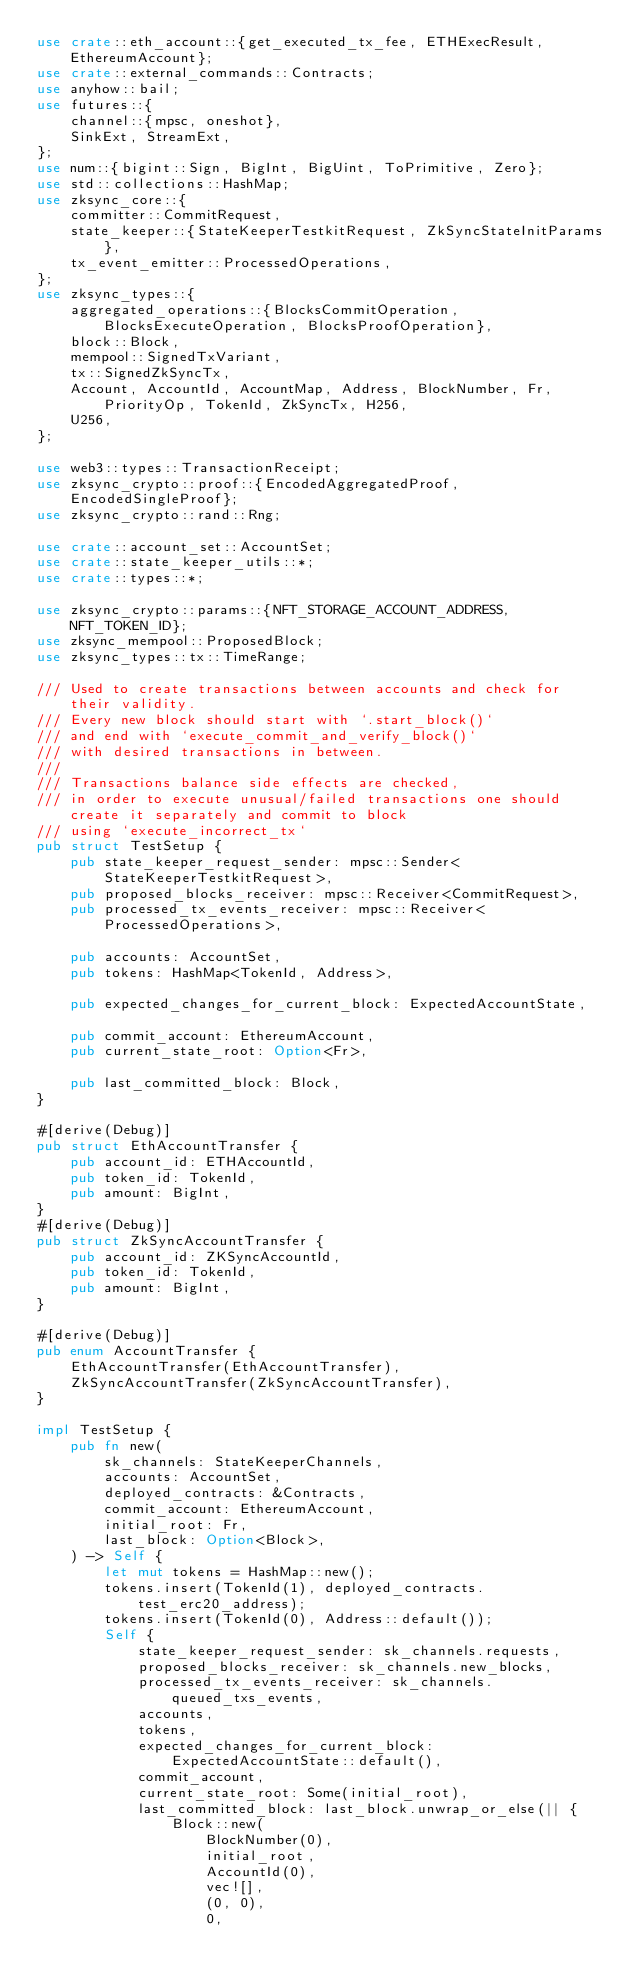Convert code to text. <code><loc_0><loc_0><loc_500><loc_500><_Rust_>use crate::eth_account::{get_executed_tx_fee, ETHExecResult, EthereumAccount};
use crate::external_commands::Contracts;
use anyhow::bail;
use futures::{
    channel::{mpsc, oneshot},
    SinkExt, StreamExt,
};
use num::{bigint::Sign, BigInt, BigUint, ToPrimitive, Zero};
use std::collections::HashMap;
use zksync_core::{
    committer::CommitRequest,
    state_keeper::{StateKeeperTestkitRequest, ZkSyncStateInitParams},
    tx_event_emitter::ProcessedOperations,
};
use zksync_types::{
    aggregated_operations::{BlocksCommitOperation, BlocksExecuteOperation, BlocksProofOperation},
    block::Block,
    mempool::SignedTxVariant,
    tx::SignedZkSyncTx,
    Account, AccountId, AccountMap, Address, BlockNumber, Fr, PriorityOp, TokenId, ZkSyncTx, H256,
    U256,
};

use web3::types::TransactionReceipt;
use zksync_crypto::proof::{EncodedAggregatedProof, EncodedSingleProof};
use zksync_crypto::rand::Rng;

use crate::account_set::AccountSet;
use crate::state_keeper_utils::*;
use crate::types::*;

use zksync_crypto::params::{NFT_STORAGE_ACCOUNT_ADDRESS, NFT_TOKEN_ID};
use zksync_mempool::ProposedBlock;
use zksync_types::tx::TimeRange;

/// Used to create transactions between accounts and check for their validity.
/// Every new block should start with `.start_block()`
/// and end with `execute_commit_and_verify_block()`
/// with desired transactions in between.
///
/// Transactions balance side effects are checked,
/// in order to execute unusual/failed transactions one should create it separately and commit to block
/// using `execute_incorrect_tx`
pub struct TestSetup {
    pub state_keeper_request_sender: mpsc::Sender<StateKeeperTestkitRequest>,
    pub proposed_blocks_receiver: mpsc::Receiver<CommitRequest>,
    pub processed_tx_events_receiver: mpsc::Receiver<ProcessedOperations>,

    pub accounts: AccountSet,
    pub tokens: HashMap<TokenId, Address>,

    pub expected_changes_for_current_block: ExpectedAccountState,

    pub commit_account: EthereumAccount,
    pub current_state_root: Option<Fr>,

    pub last_committed_block: Block,
}

#[derive(Debug)]
pub struct EthAccountTransfer {
    pub account_id: ETHAccountId,
    pub token_id: TokenId,
    pub amount: BigInt,
}
#[derive(Debug)]
pub struct ZkSyncAccountTransfer {
    pub account_id: ZKSyncAccountId,
    pub token_id: TokenId,
    pub amount: BigInt,
}

#[derive(Debug)]
pub enum AccountTransfer {
    EthAccountTransfer(EthAccountTransfer),
    ZkSyncAccountTransfer(ZkSyncAccountTransfer),
}

impl TestSetup {
    pub fn new(
        sk_channels: StateKeeperChannels,
        accounts: AccountSet,
        deployed_contracts: &Contracts,
        commit_account: EthereumAccount,
        initial_root: Fr,
        last_block: Option<Block>,
    ) -> Self {
        let mut tokens = HashMap::new();
        tokens.insert(TokenId(1), deployed_contracts.test_erc20_address);
        tokens.insert(TokenId(0), Address::default());
        Self {
            state_keeper_request_sender: sk_channels.requests,
            proposed_blocks_receiver: sk_channels.new_blocks,
            processed_tx_events_receiver: sk_channels.queued_txs_events,
            accounts,
            tokens,
            expected_changes_for_current_block: ExpectedAccountState::default(),
            commit_account,
            current_state_root: Some(initial_root),
            last_committed_block: last_block.unwrap_or_else(|| {
                Block::new(
                    BlockNumber(0),
                    initial_root,
                    AccountId(0),
                    vec![],
                    (0, 0),
                    0,</code> 